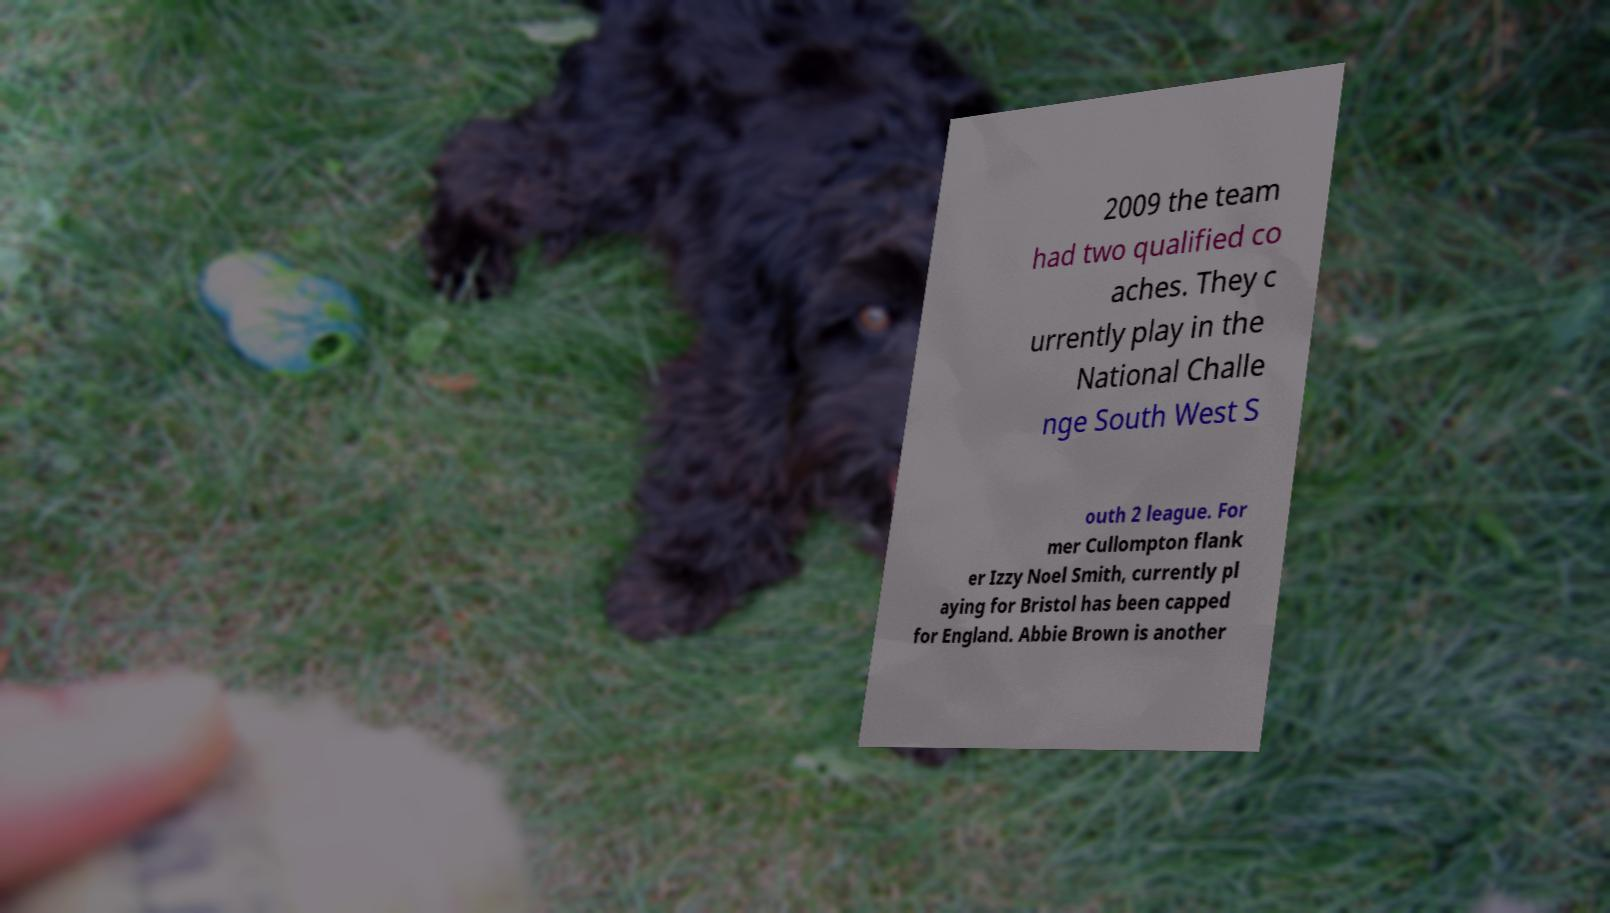What messages or text are displayed in this image? I need them in a readable, typed format. 2009 the team had two qualified co aches. They c urrently play in the National Challe nge South West S outh 2 league. For mer Cullompton flank er Izzy Noel Smith, currently pl aying for Bristol has been capped for England. Abbie Brown is another 